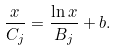<formula> <loc_0><loc_0><loc_500><loc_500>\frac { x } { C _ { j } } = \frac { \ln x } { B _ { j } } + b .</formula> 